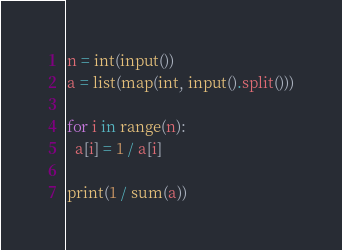<code> <loc_0><loc_0><loc_500><loc_500><_Python_>n = int(input())
a = list(map(int, input().split()))

for i in range(n):
  a[i] = 1 / a[i]

print(1 / sum(a))</code> 